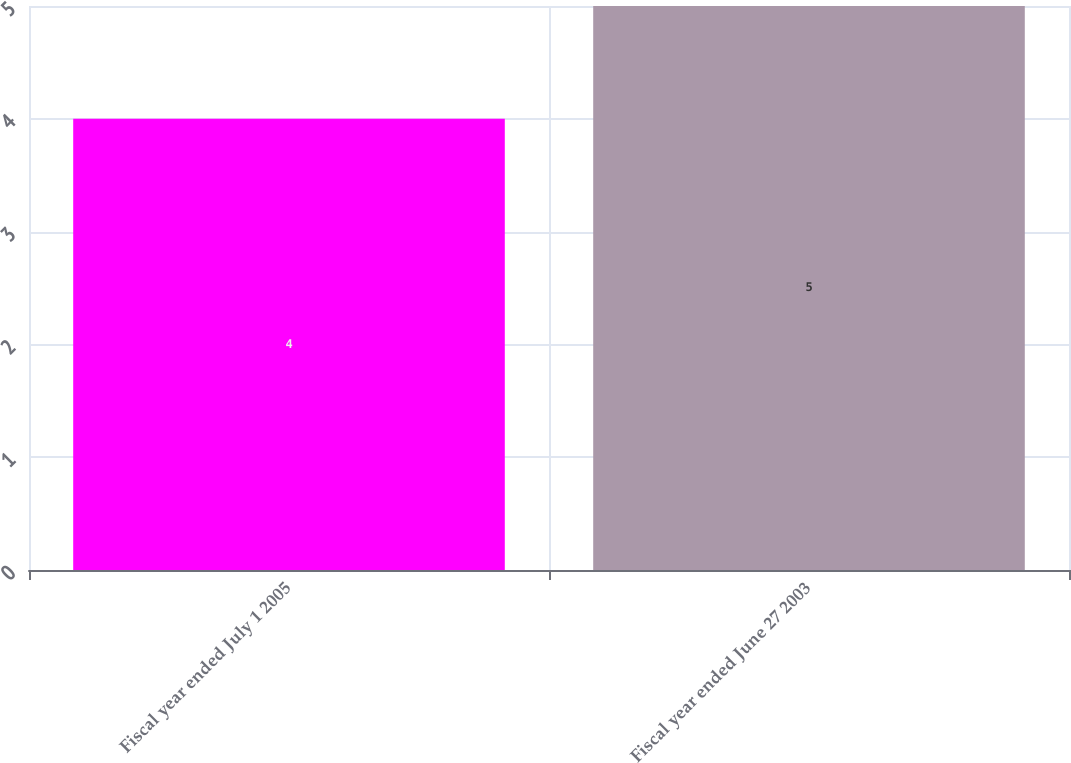<chart> <loc_0><loc_0><loc_500><loc_500><bar_chart><fcel>Fiscal year ended July 1 2005<fcel>Fiscal year ended June 27 2003<nl><fcel>4<fcel>5<nl></chart> 